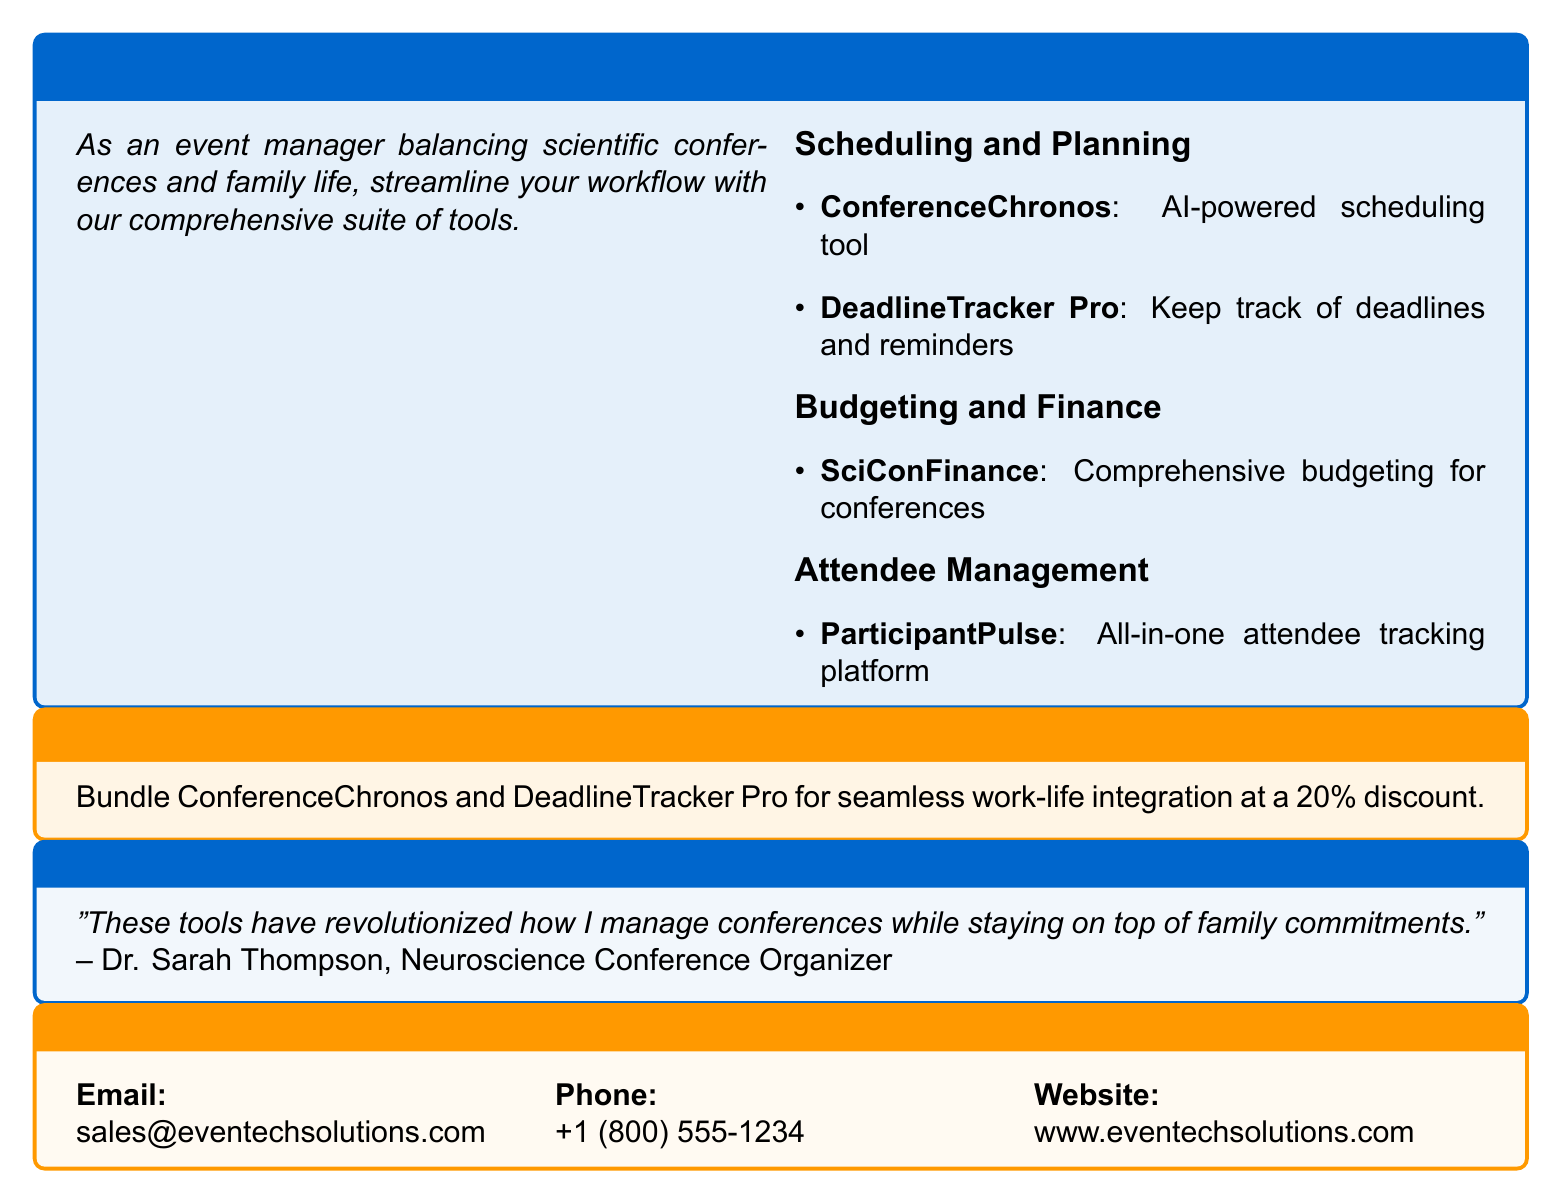what is the name of the AI-powered scheduling tool? The document lists "ConferenceChronos" as the AI-powered scheduling tool available in the professional event management software.
Answer: ConferenceChronos what is included in the family-friendly package? The family-friendly package promotes the combination of ConferenceChronos and DeadlineTracker Pro at a discounted rate for work-life integration.
Answer: Bundle ConferenceChronos and DeadlineTracker Pro how much discount is offered in the family-friendly package? The document specifies a 20% discount for the family-friendly package that bundles two specific tools.
Answer: 20% who is the testimonial from? The testimonial in the document is attributed to a conference organizer who finds the tools helpful, specifically named Dr. Sarah Thompson.
Answer: Dr. Sarah Thompson what is the website for Eventech Solutions? The document provides a website for the company Eventech Solutions for more information about their offerings.
Answer: www.eventechsolutions.com what tool is used for attendee tracking? The document identifies "ParticipantPulse" as the software platform specifically mentioned for managing and tracking attendees at events.
Answer: ParticipantPulse what are the features mentioned under budgeting and finance? The document outlines that SciConFinance is the comprehensive tool for budgeting for conferences, indicating its specific purpose in financial management within event organization.
Answer: SciConFinance how many items are listed under scheduling and planning? The document lists two specific tools under scheduling and planning, allowing for a clear count of available options for event managers in that category.
Answer: 2 